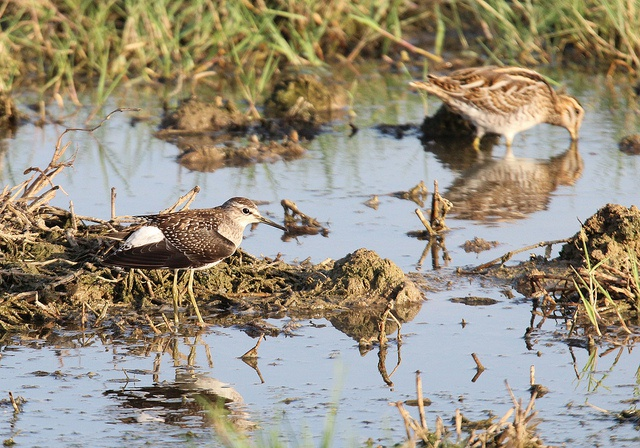Describe the objects in this image and their specific colors. I can see bird in maroon, black, and ivory tones and bird in maroon and tan tones in this image. 